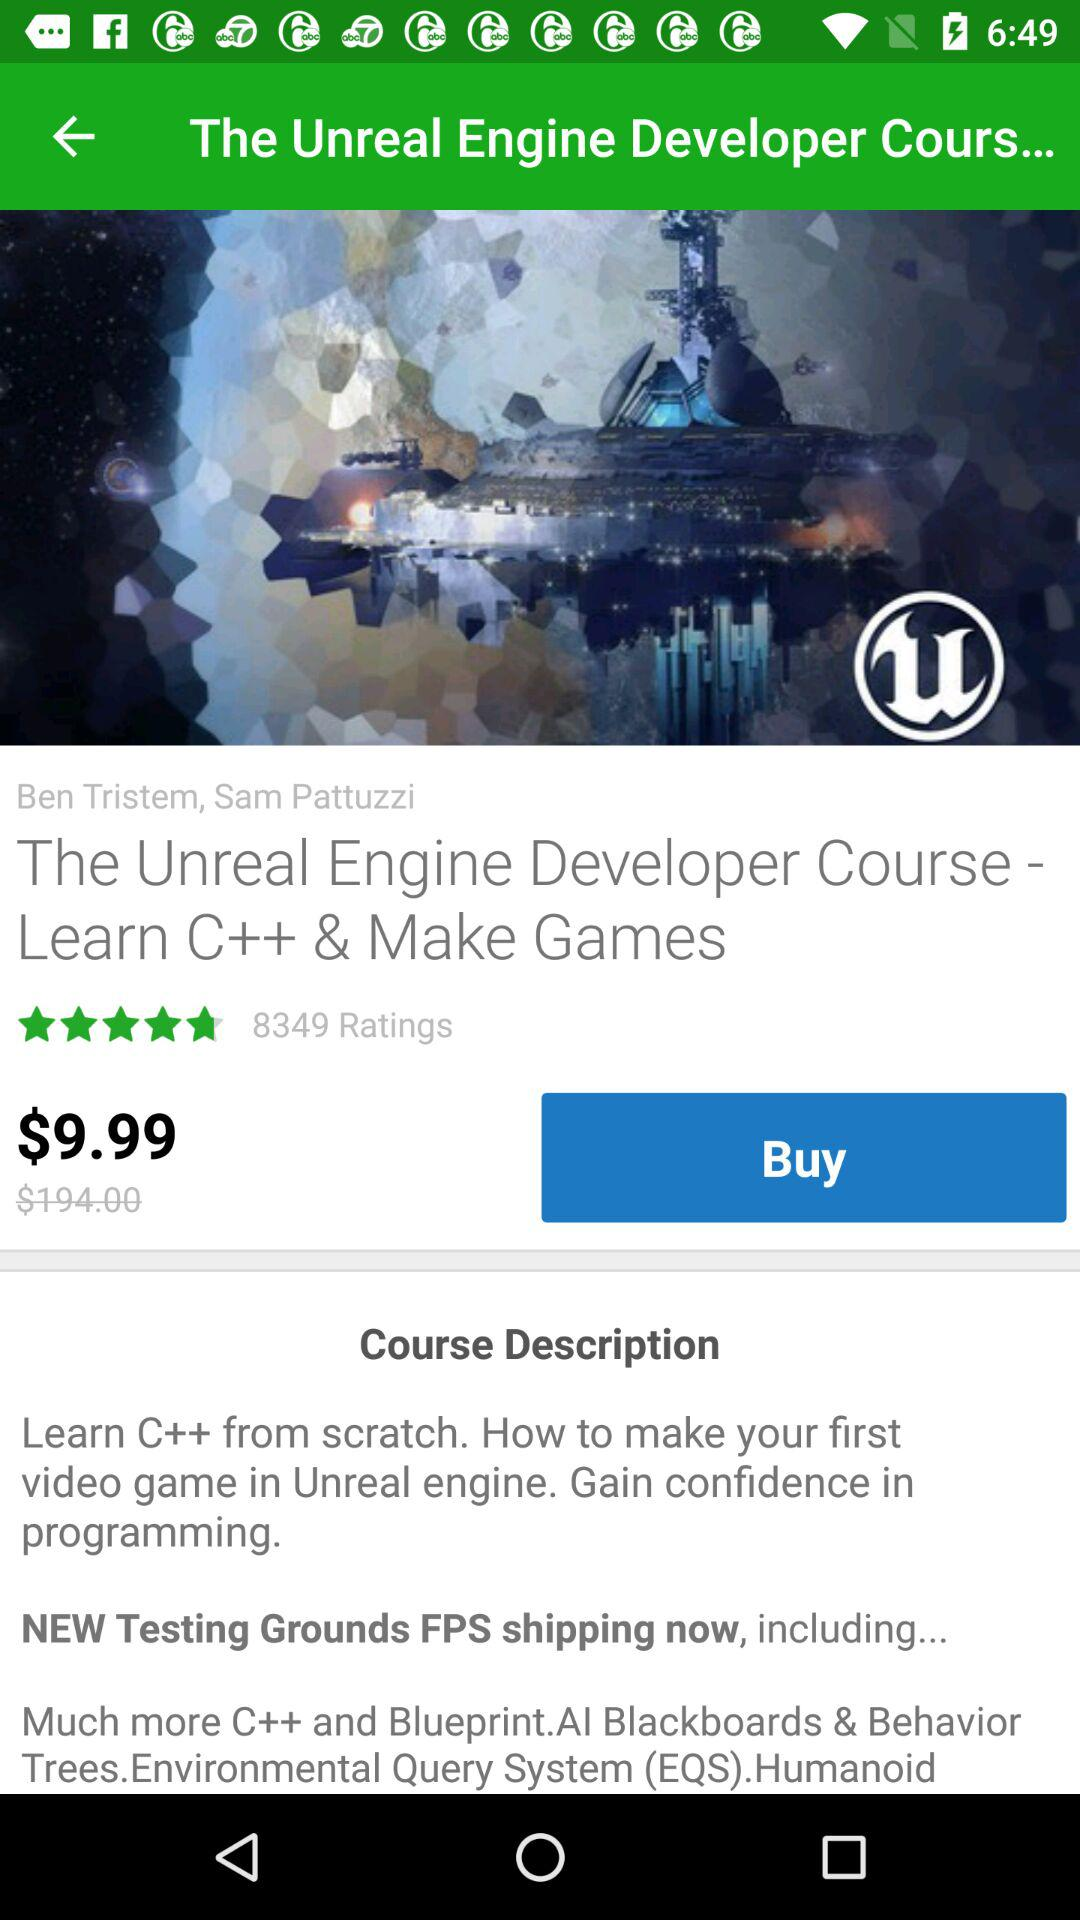What's the tutor's name for the course? The names of the tutors are Ben Tristem and Sam Pattuzzi. 